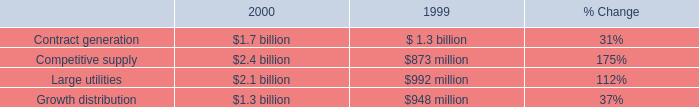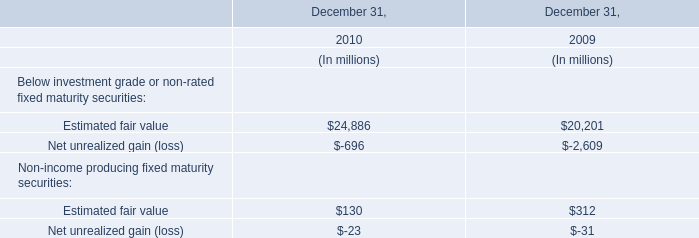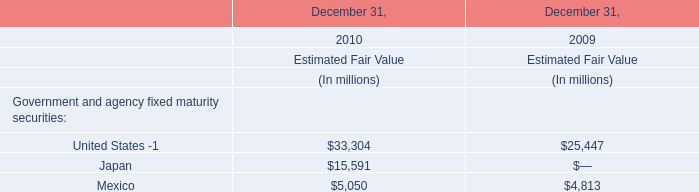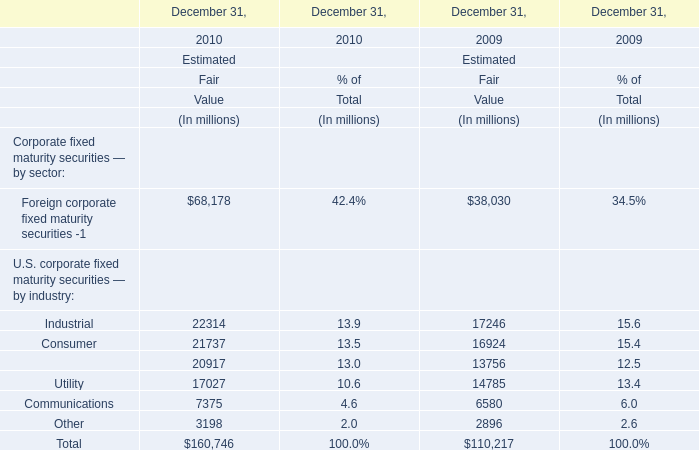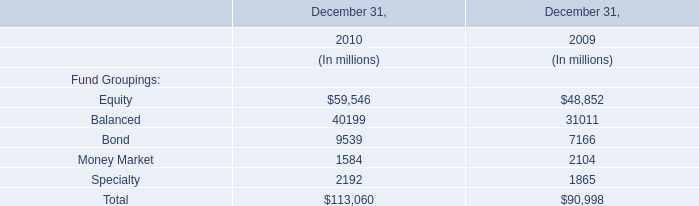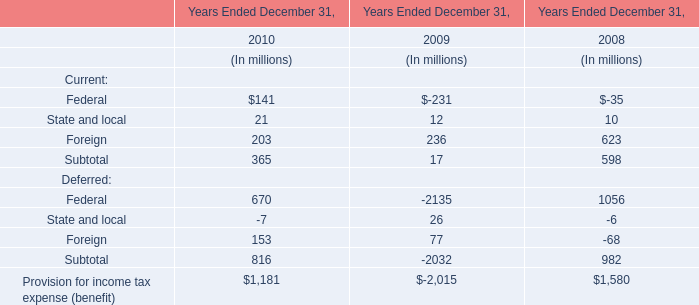Does Foreign corporate fixed maturity securities -1 keeps increasing each year between 2009 and 2010 ? 
Answer: yes. 